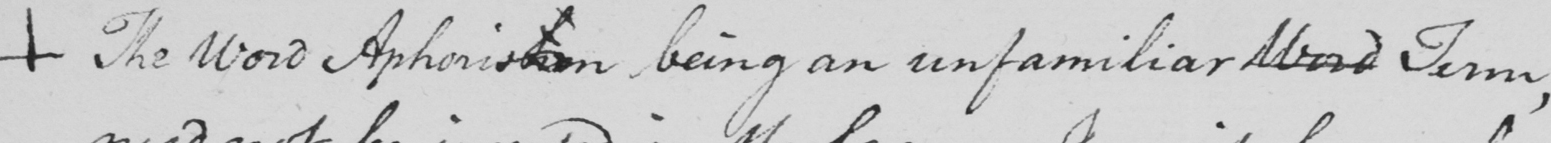What does this handwritten line say? +  The Word Aphorism being an unfamiliar Word Term , 